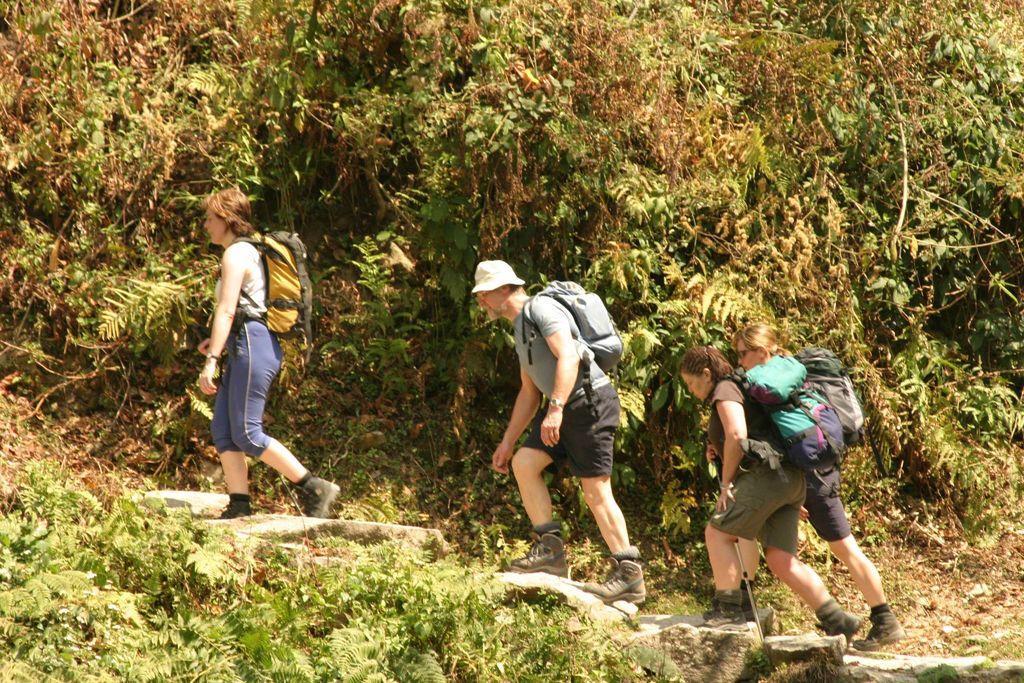Describe this image in one or two sentences. In this picture we can see a group of people walking on a path, they are wearing bags and in the background we can see trees. 